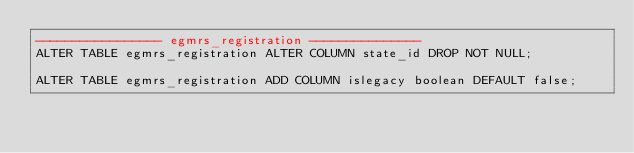<code> <loc_0><loc_0><loc_500><loc_500><_SQL_>----------------- egmrs_registration ---------------
ALTER TABLE egmrs_registration ALTER COLUMN state_id DROP NOT NULL;

ALTER TABLE egmrs_registration ADD COLUMN islegacy boolean DEFAULT false;
</code> 